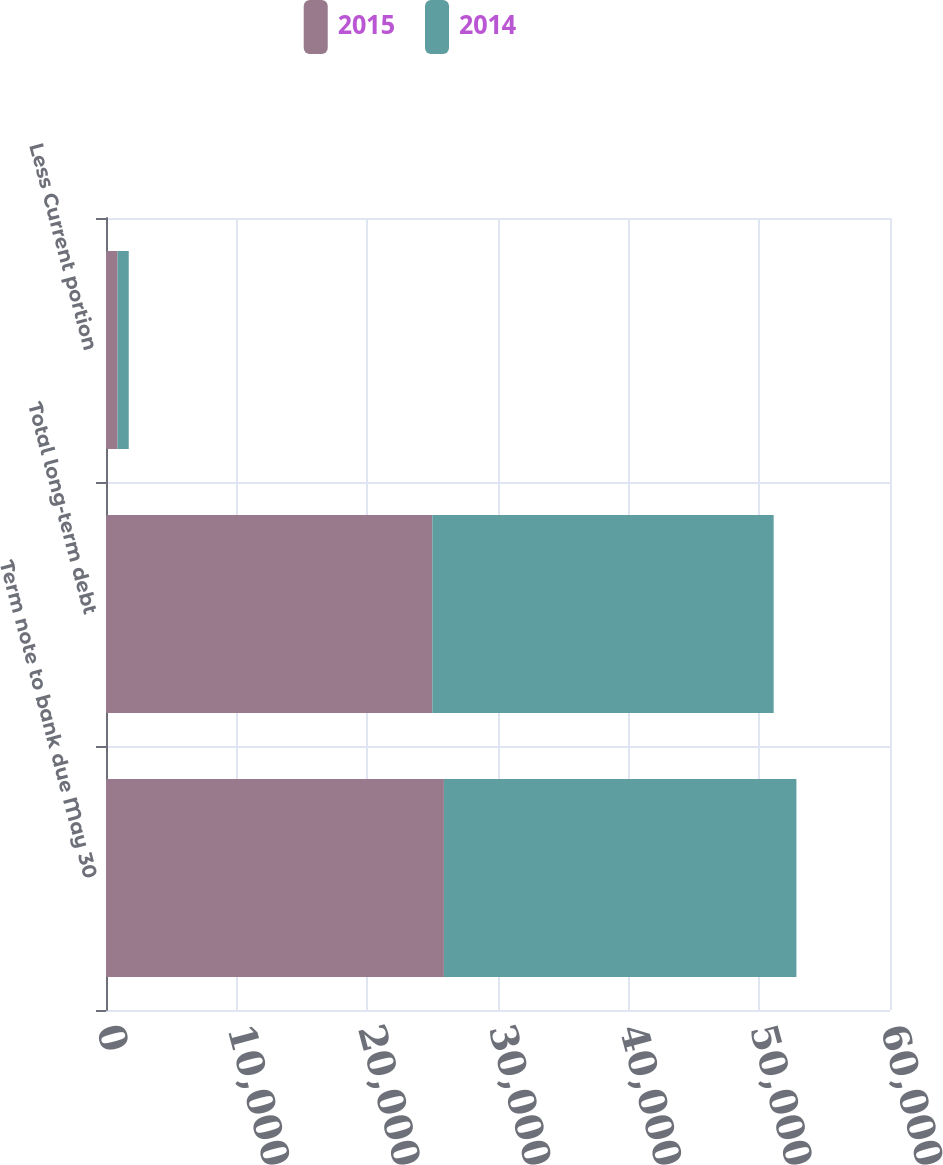Convert chart to OTSL. <chart><loc_0><loc_0><loc_500><loc_500><stacked_bar_chart><ecel><fcel>Term note to bank due May 30<fcel>Total long-term debt<fcel>Less Current portion<nl><fcel>2015<fcel>25860<fcel>24974<fcel>886<nl><fcel>2014<fcel>26978<fcel>26123<fcel>855<nl></chart> 